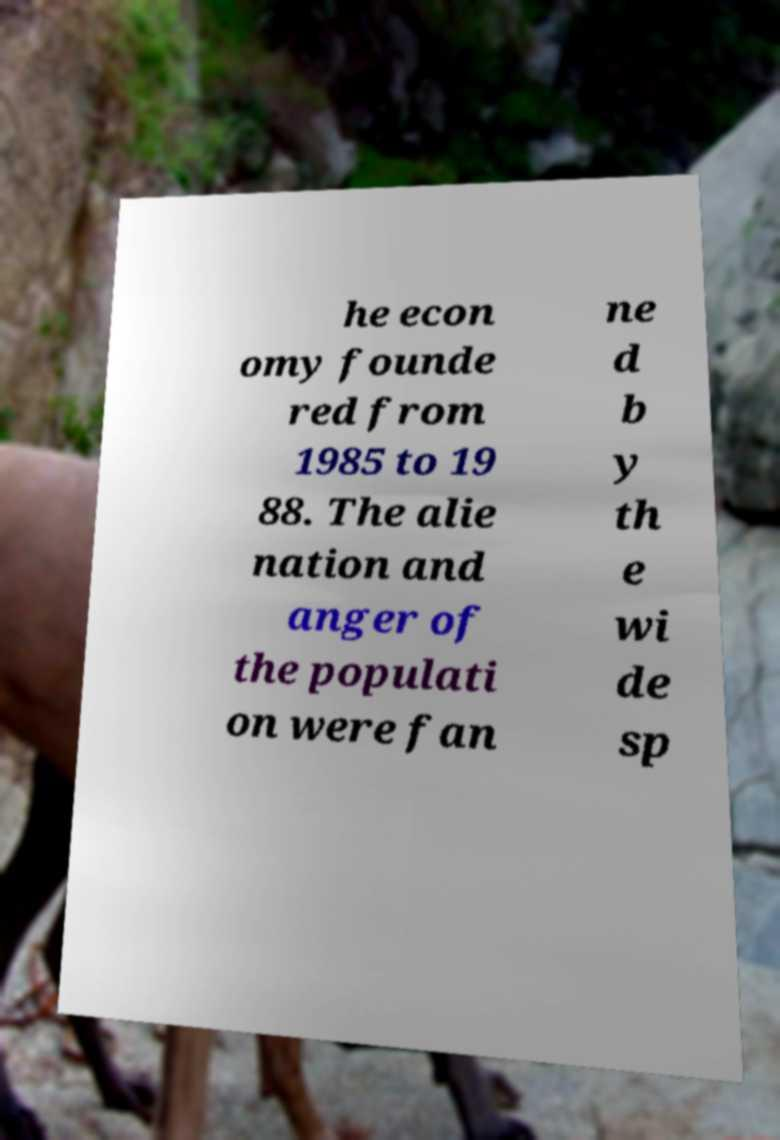I need the written content from this picture converted into text. Can you do that? he econ omy founde red from 1985 to 19 88. The alie nation and anger of the populati on were fan ne d b y th e wi de sp 